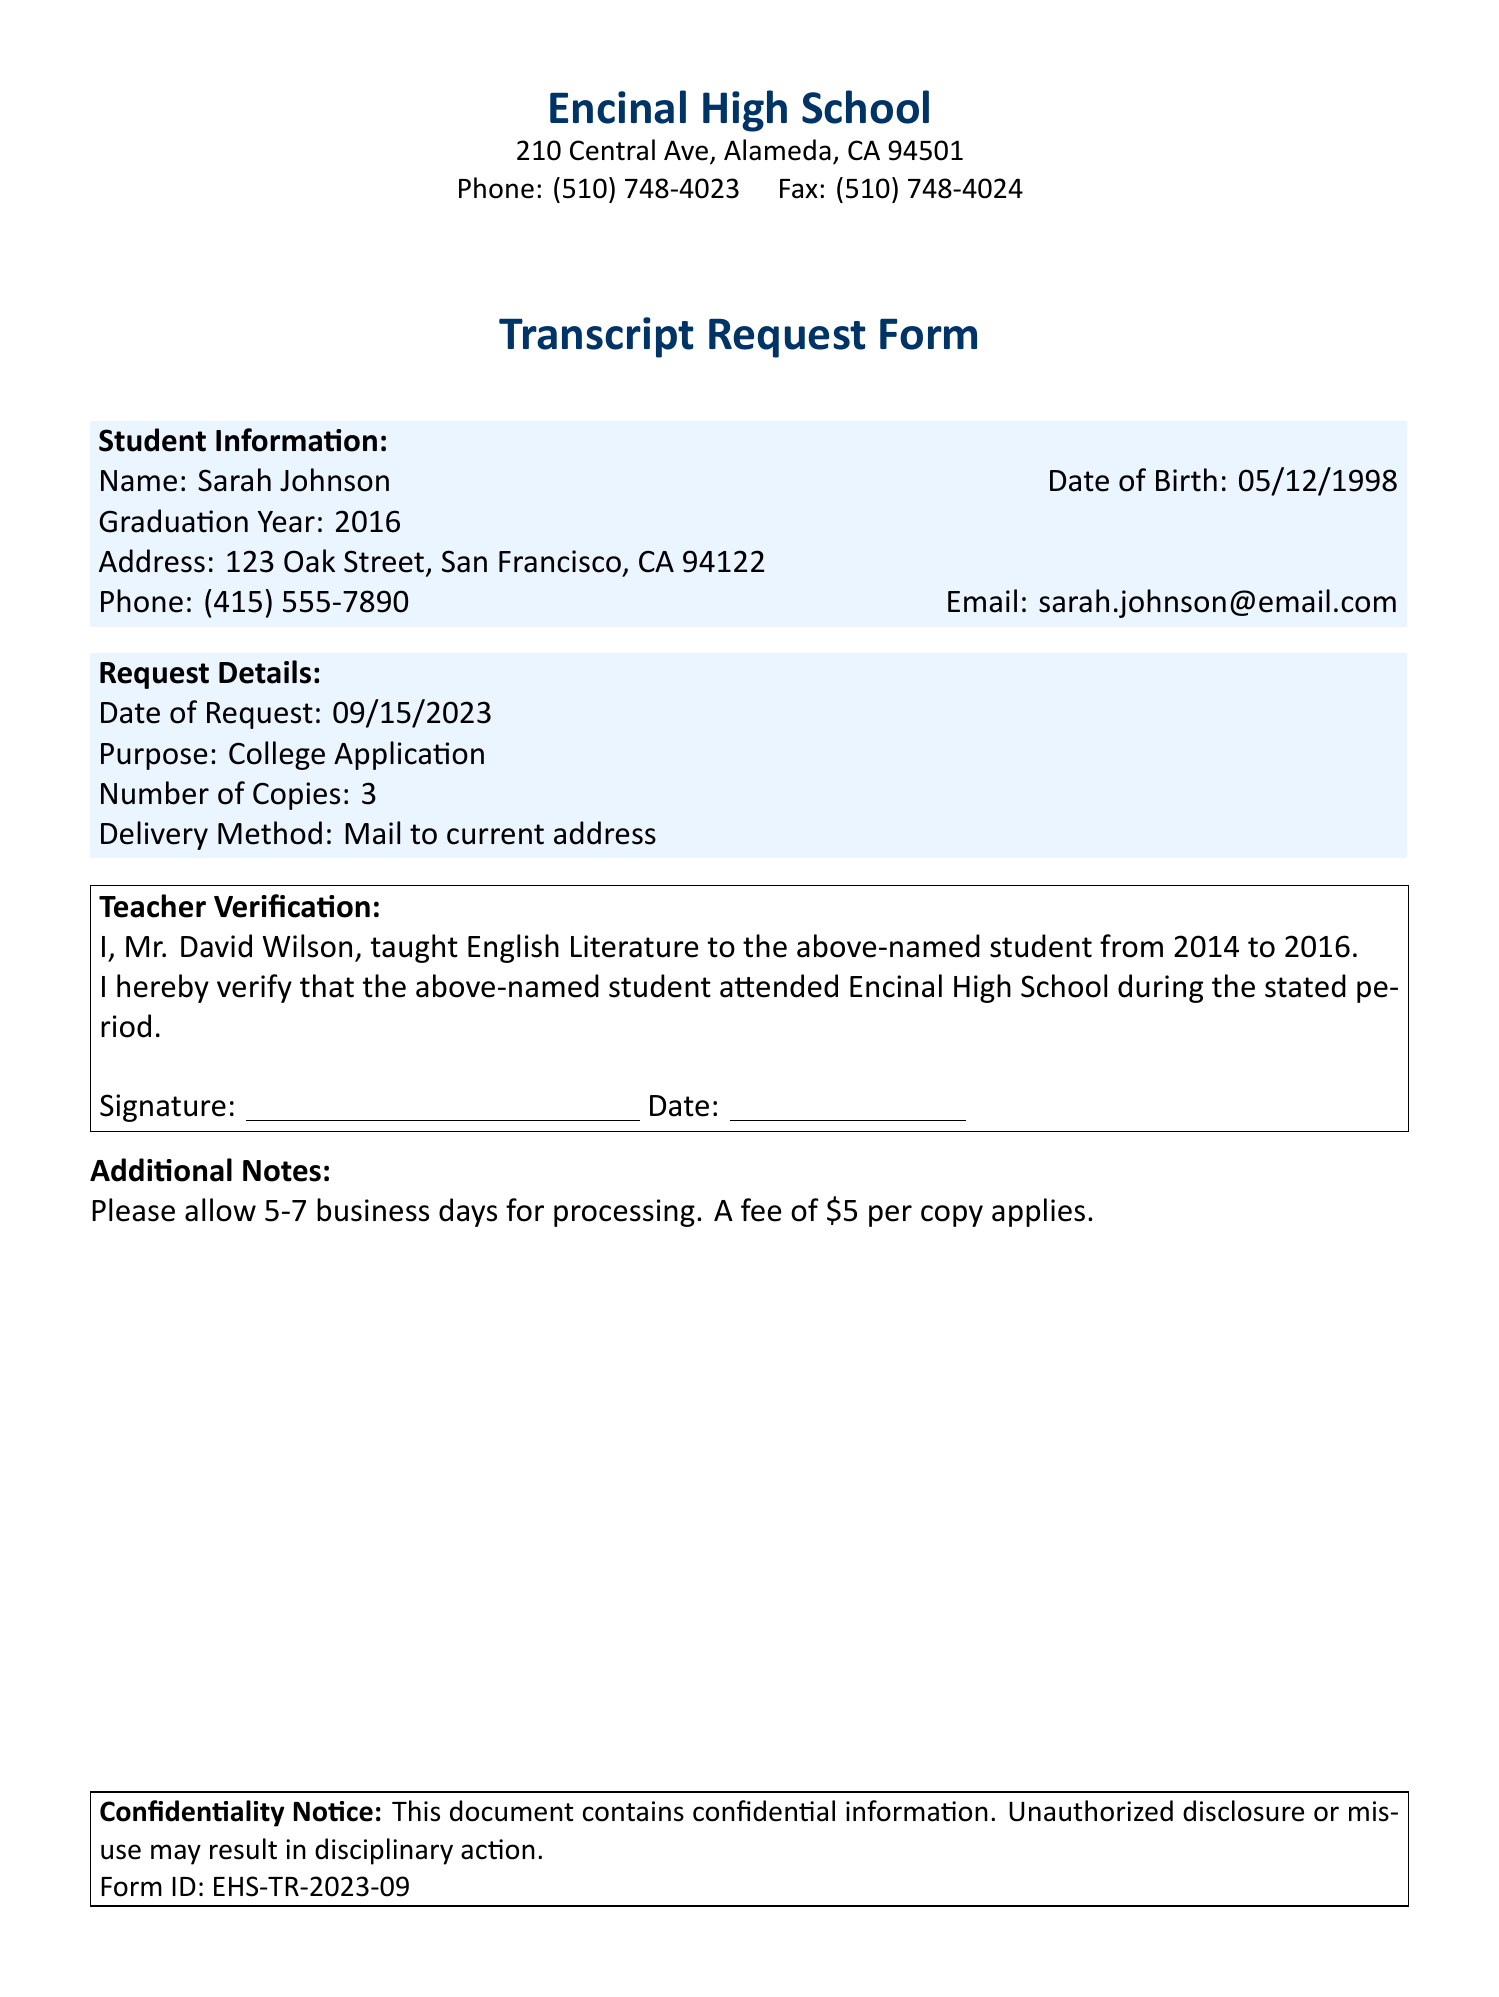What is the name of the student requesting the transcript? The document states the student's name is Sarah Johnson.
Answer: Sarah Johnson What is the graduation year of the student? The document specifies that the student graduated in the year 2016.
Answer: 2016 Who is the teacher verifying the student's attendance? The teacher verifying the attendance is Mr. David Wilson.
Answer: Mr. David Wilson What is the purpose of the transcript request? The document indicates that the purpose is for a college application.
Answer: College Application How many copies of the transcript are requested? The document mentions that the number of copies requested is three.
Answer: 3 What is the date of the request? The document lists the date of the request as September 15, 2023.
Answer: 09/15/2023 What is the processing time mentioned in the document? The document states to allow 5-7 business days for processing.
Answer: 5-7 business days What fee is associated with each copy of the transcript? The document specifies a fee of five dollars per copy.
Answer: $5 What was the teacher's subject? The document indicates that the teacher taught English Literature to the student.
Answer: English Literature 